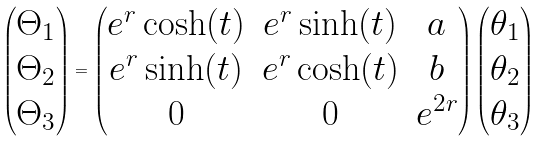<formula> <loc_0><loc_0><loc_500><loc_500>\left ( \begin{matrix} \Theta _ { 1 } \\ \Theta _ { 2 } \\ \Theta _ { 3 } \end{matrix} \right ) = \left ( \begin{matrix} e ^ { r } \cosh ( t ) & e ^ { r } \sinh ( t ) & a \\ e ^ { r } \sinh ( t ) & e ^ { r } \cosh ( t ) & b \\ 0 & 0 & e ^ { 2 r } \end{matrix} \right ) \left ( \begin{matrix} \theta _ { 1 } \\ \theta _ { 2 } \\ \theta _ { 3 } \end{matrix} \right )</formula> 